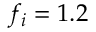<formula> <loc_0><loc_0><loc_500><loc_500>f _ { i } = 1 . 2</formula> 